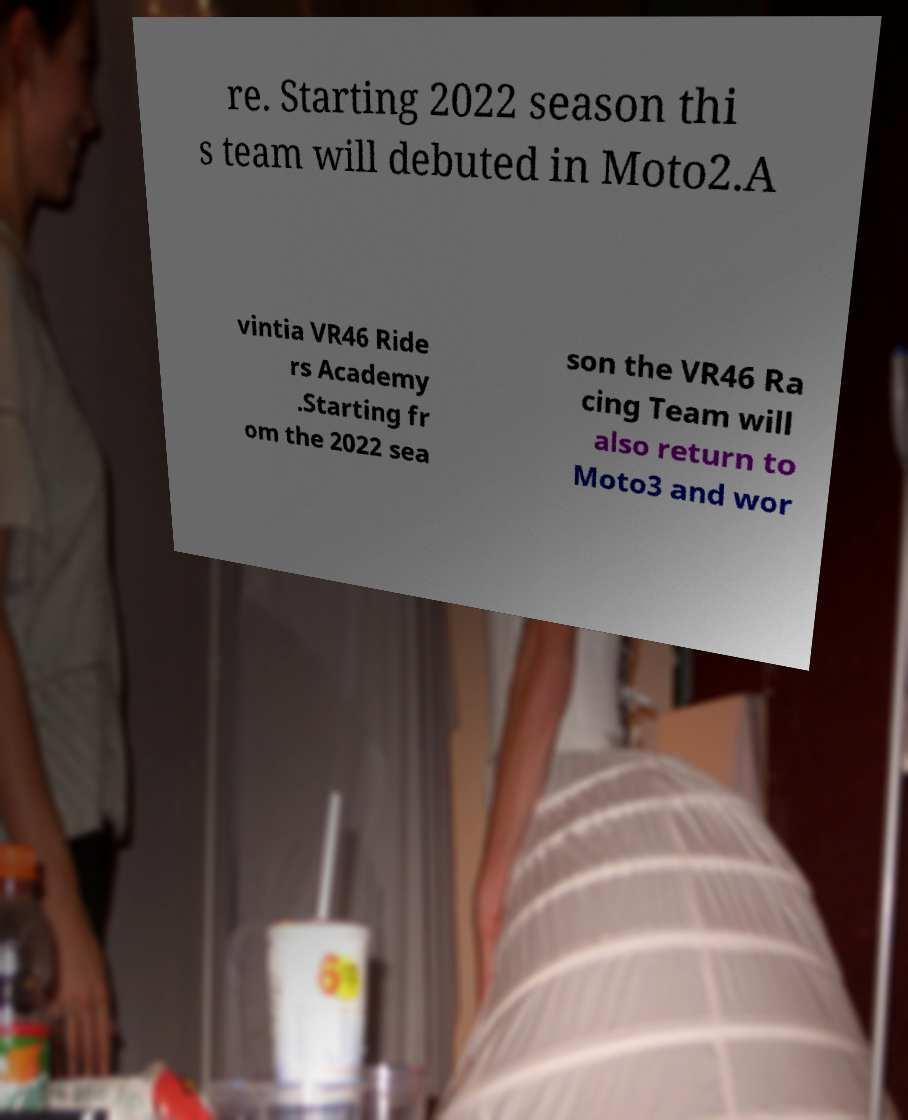Could you extract and type out the text from this image? re. Starting 2022 season thi s team will debuted in Moto2.A vintia VR46 Ride rs Academy .Starting fr om the 2022 sea son the VR46 Ra cing Team will also return to Moto3 and wor 